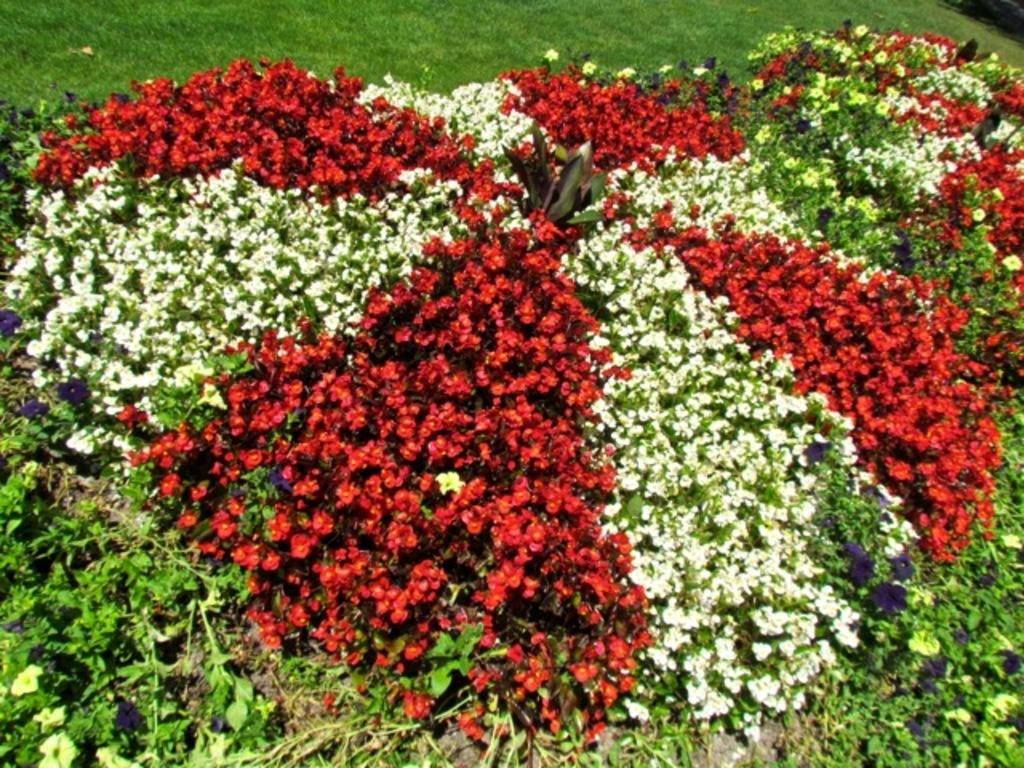What type of living organisms can be seen in the image? Flowers and plants can be seen in the image. Can you describe the natural setting visible in the image? There is grass visible in the background of the image. What type of soup can be seen being served in the image? There is no soup present in the image; it features flowers, plants, and grass. How many cherries can be seen hanging from the flowers in the image? There are no cherries present in the image, as it features flowers, plants, and grass. 